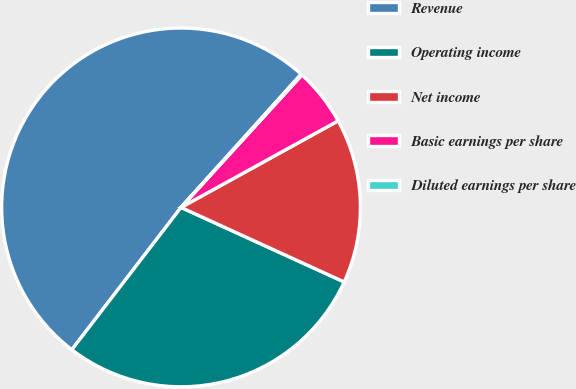Convert chart. <chart><loc_0><loc_0><loc_500><loc_500><pie_chart><fcel>Revenue<fcel>Operating income<fcel>Net income<fcel>Basic earnings per share<fcel>Diluted earnings per share<nl><fcel>51.26%<fcel>28.6%<fcel>14.84%<fcel>5.21%<fcel>0.1%<nl></chart> 